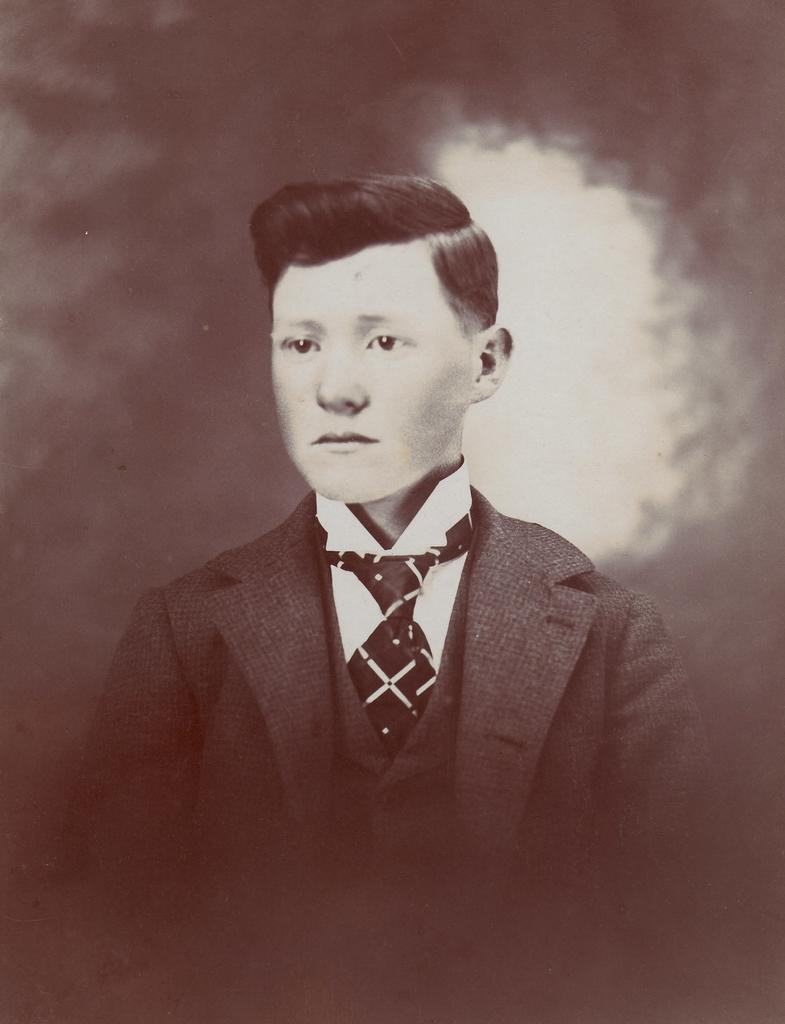What is the main subject of the image? There is a person in the image. What type of clothing is the person wearing on their upper body? The person is wearing a blazer, a shirt, and a tie. What type of brick is being used for the development of the person's root system in the image? There is no brick, development, or root system present in the image; it features a person wearing a blazer, shirt, and tie. 